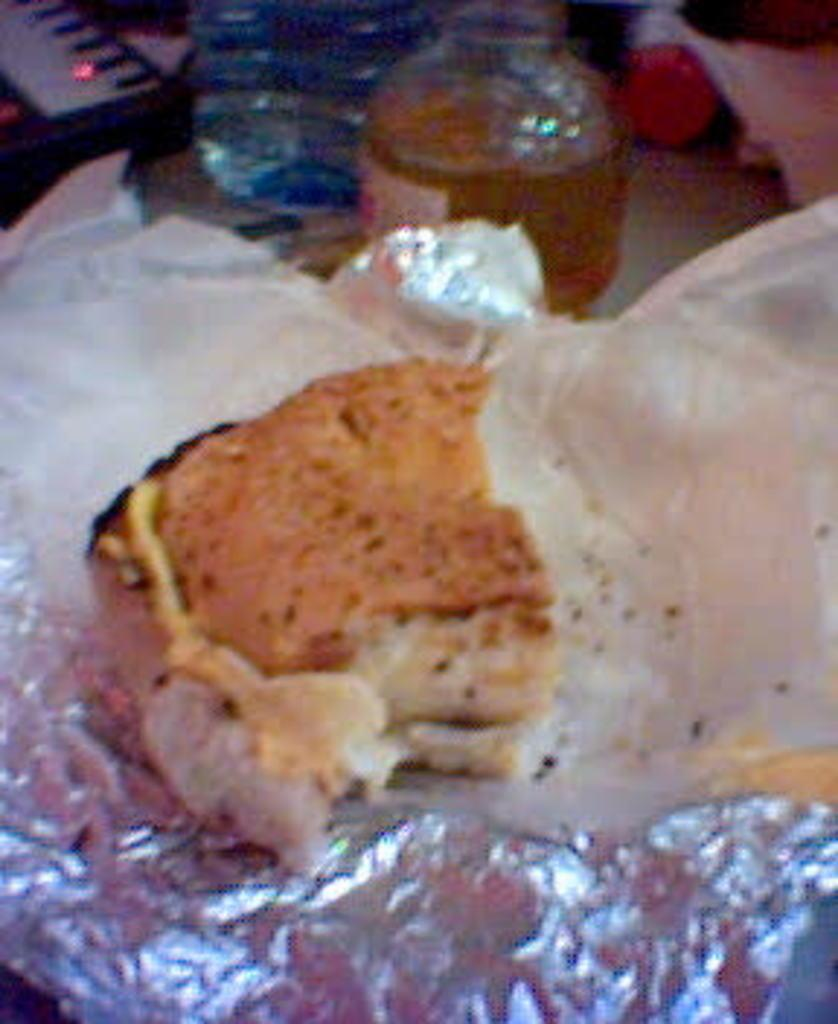What is the main subject of the image? The main subject of the image is food. Where is the food located in the image? The food is in the center of the image. What else can be seen in the image besides the food? There are bottles in the image. Where are the bottles located in the image? The bottles are on the top of the image. What type of book is being used as a doorstop in the image? There is no book or doorstop present in the image. 